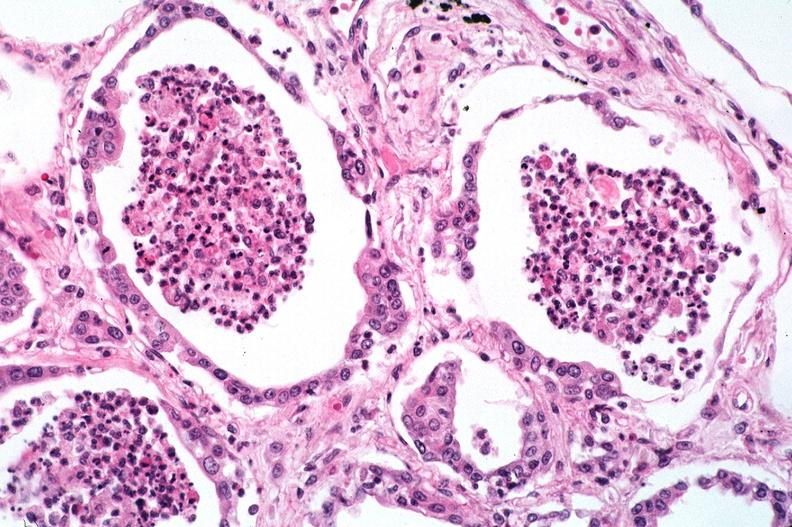what does this image show?
Answer the question using a single word or phrase. Lung 